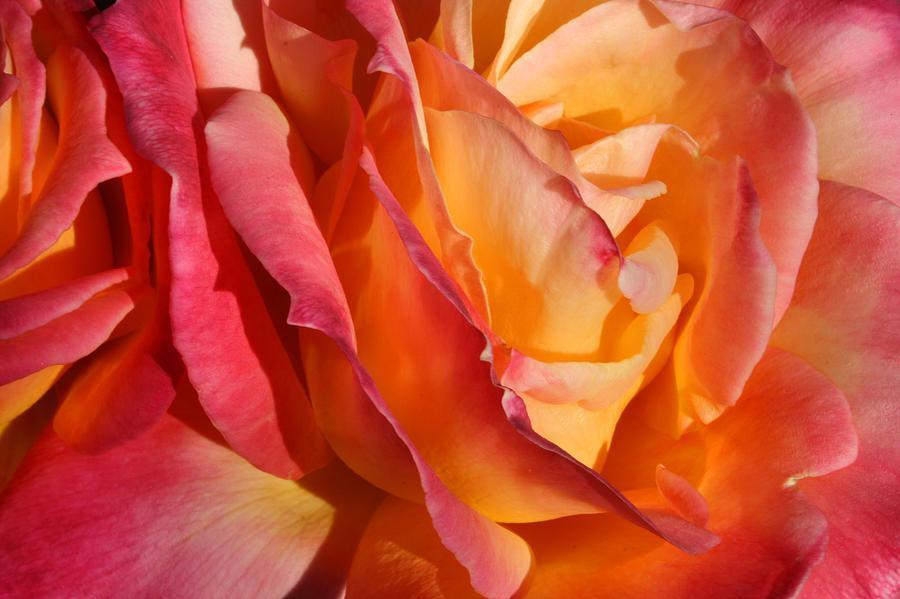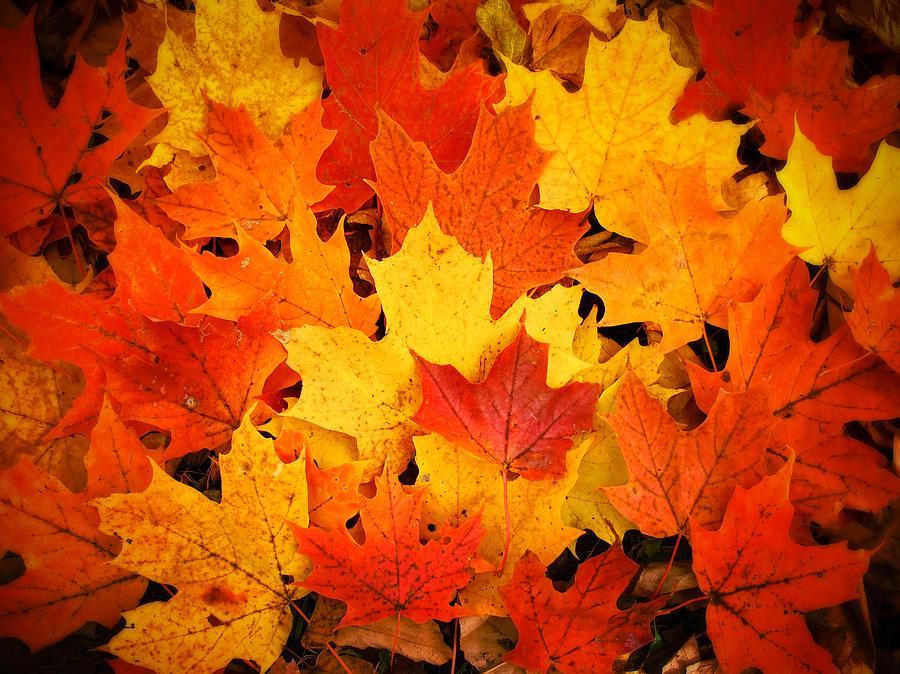The first image is the image on the left, the second image is the image on the right. For the images displayed, is the sentence "The right image shows a bunch of autumn leaves shaped like maple leaves." factually correct? Answer yes or no. Yes. 